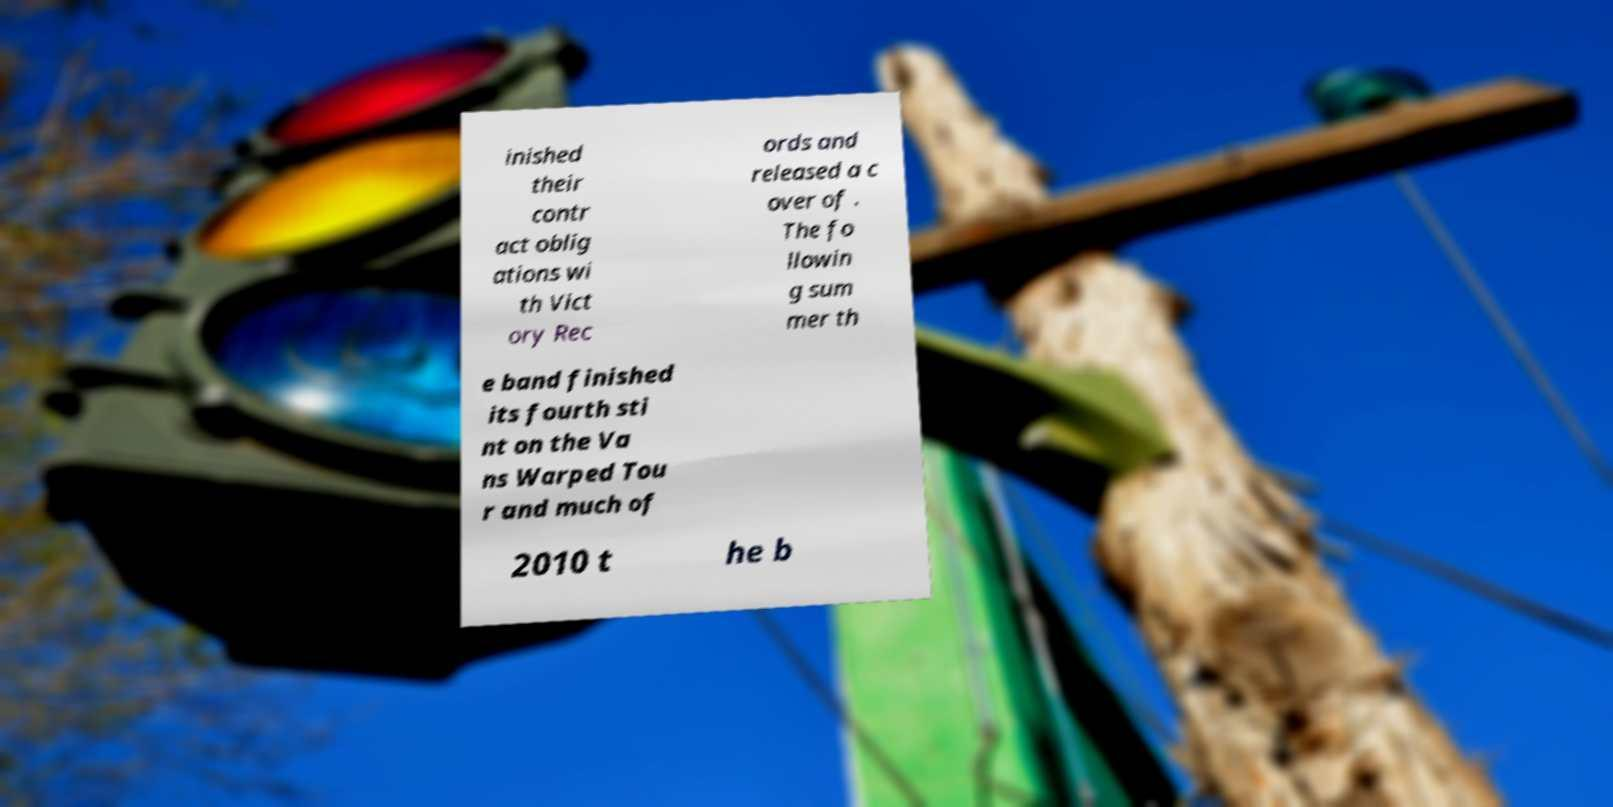Could you extract and type out the text from this image? inished their contr act oblig ations wi th Vict ory Rec ords and released a c over of . The fo llowin g sum mer th e band finished its fourth sti nt on the Va ns Warped Tou r and much of 2010 t he b 